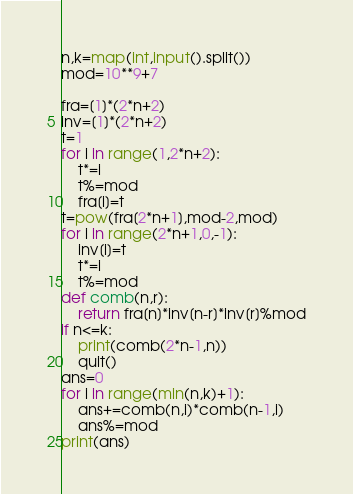Convert code to text. <code><loc_0><loc_0><loc_500><loc_500><_Python_>n,k=map(int,input().split())
mod=10**9+7

fra=[1]*(2*n+2)
inv=[1]*(2*n+2)
t=1
for i in range(1,2*n+2):
    t*=i
    t%=mod
    fra[i]=t
t=pow(fra[2*n+1],mod-2,mod)
for i in range(2*n+1,0,-1):
    inv[i]=t
    t*=i
    t%=mod
def comb(n,r):
    return fra[n]*inv[n-r]*inv[r]%mod
if n<=k:
    print(comb(2*n-1,n))
    quit()
ans=0
for i in range(min(n,k)+1):
    ans+=comb(n,i)*comb(n-1,i)
    ans%=mod
print(ans)</code> 